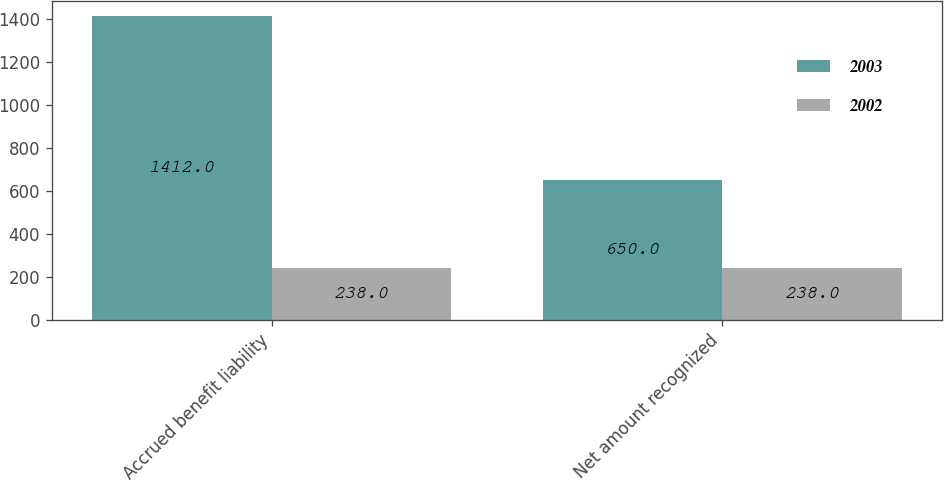Convert chart to OTSL. <chart><loc_0><loc_0><loc_500><loc_500><stacked_bar_chart><ecel><fcel>Accrued benefit liability<fcel>Net amount recognized<nl><fcel>2003<fcel>1412<fcel>650<nl><fcel>2002<fcel>238<fcel>238<nl></chart> 